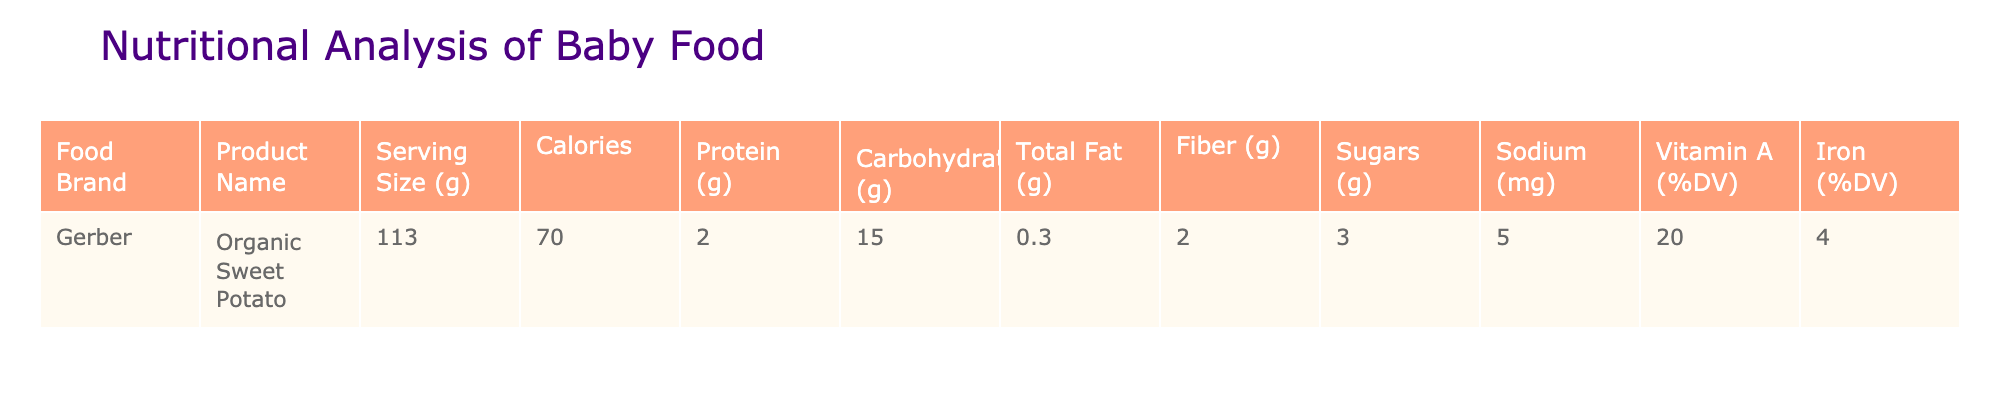What is the serving size of the Organic Sweet Potato? The table indicates that the serving size for Gerber's Organic Sweet Potato is 113 grams.
Answer: 113 grams How many calories are in a serving of Organic Sweet Potato? Looking at the table, it shows that there are 70 calories in a serving of Organic Sweet Potato.
Answer: 70 calories What is the amount of protein in this baby food? The table lists the protein content as 2 grams for the Organic Sweet Potato.
Answer: 2 grams Is there any added sugar in the Organic Sweet Potato? The data shows that the sugar content is 3 grams, which indicates that there is indeed some sugar present in this baby food.
Answer: Yes What percentage of Vitamin A is provided by the Organic Sweet Potato? The table states that the Organic Sweet Potato provides 20% of the daily value of Vitamin A per serving.
Answer: 20% What is the total fat content in the Organic Sweet Potato? According to the table, the total fat content is 0.3 grams for the Organic Sweet Potato.
Answer: 0.3 grams If a parent were comparing this to a food that had 5 grams of fiber, how much less fiber does the Organic Sweet Potato have? The fiber content of Organic Sweet Potato is 2 grams. To find the difference, subtract the fiber content of Organic Sweet Potato from the other food: 5 grams - 2 grams = 3 grams.
Answer: 3 grams less What is the total carbohydrate content in the Organic Sweet Potato? From the table, the total carbohydrate content is stated to be 15 grams.
Answer: 15 grams Does the Organic Sweet Potato have any sodium? The sodium content in the table is 5 mg, indicating that there is a small amount of sodium present in this baby food.
Answer: Yes 